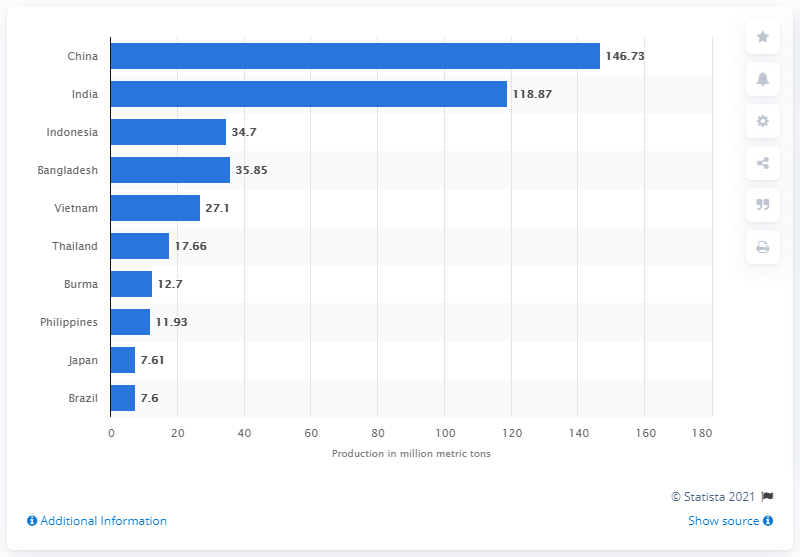Specify some key components in this picture. According to the 2019/2020 crop year, China produced a total of 146.73 million metric tons of milled rice. India produced the second-highest amount of milled rice, at 118.9 million metric tons, in the 2019/2020 crop year. 